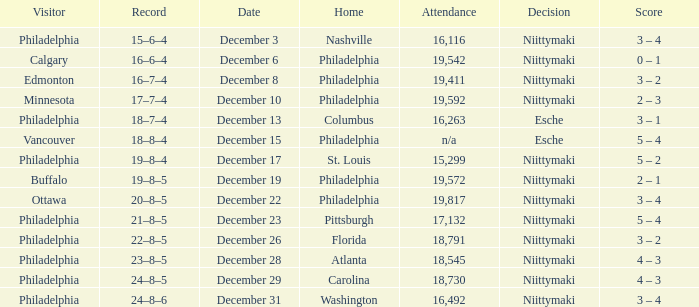What was the score when the attendance was 18,545? 4 – 3. 